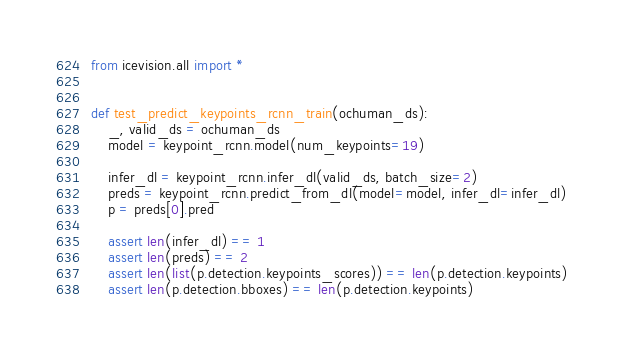Convert code to text. <code><loc_0><loc_0><loc_500><loc_500><_Python_>from icevision.all import *


def test_predict_keypoints_rcnn_train(ochuman_ds):
    _, valid_ds = ochuman_ds
    model = keypoint_rcnn.model(num_keypoints=19)

    infer_dl = keypoint_rcnn.infer_dl(valid_ds, batch_size=2)
    preds = keypoint_rcnn.predict_from_dl(model=model, infer_dl=infer_dl)
    p = preds[0].pred

    assert len(infer_dl) == 1
    assert len(preds) == 2
    assert len(list(p.detection.keypoints_scores)) == len(p.detection.keypoints)
    assert len(p.detection.bboxes) == len(p.detection.keypoints)
</code> 